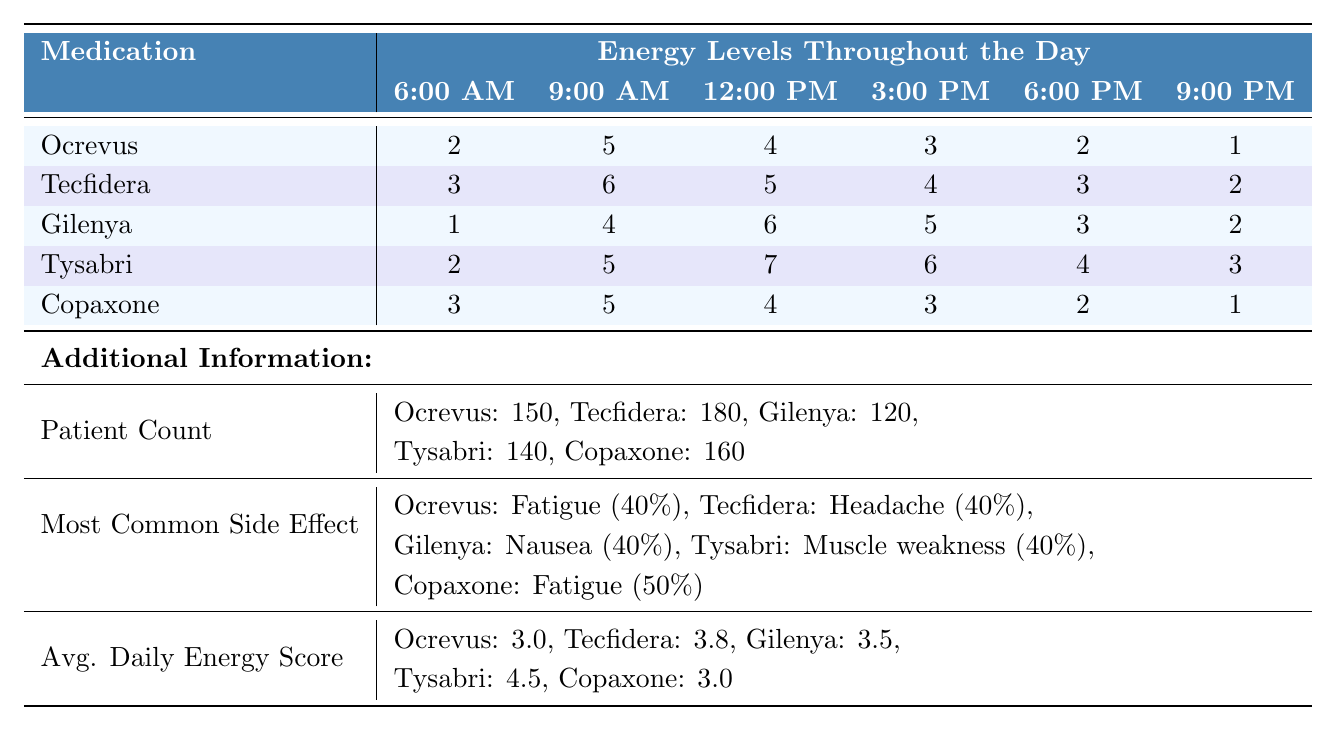What is the energy level for patients taking Tysabri at 12:00 PM? Referring to the table, the energy level for Tysabri at 12:00 PM is found in the corresponding cell, which shows the value of 7.
Answer: 7 What medication shows the highest average daily energy score? The average daily energy scores for each medication are listed. Comparing these values, Tysabri has the highest score at 4.5.
Answer: Tysabri How many patients are on Tecfidera? The table provides the patient count for Tecfidera, which is explicitly mentioned as 180.
Answer: 180 Which medication has the most common side effect of fatigue? By checking the side effects for each medication, we note that Ocrevus and Copaxone both list fatigue as a side effect, but Ocrevus has a frequency of 40%.
Answer: Ocrevus What is the difference in energy level at 9:00 AM between Gilenya and Copaxone? The energy level for Gilenya at 9:00 AM is 4, while Copaxone's is 5. The difference is calculated as 5 - 4 = 1.
Answer: 1 Which time of day has the highest average energy level across all medications? Calculating the average energy level for each time of day involves summing the values for each medication at that time. For example, for 6:00 AM: (2 + 3 + 1 + 2 + 3) = 11, divided by 5 gives an average of 2.2. After calculating, it is found that 12:00 PM has the highest average of 5.
Answer: 12:00 PM Is the side effect of nausea more common for Gilenya or Tecfidera? Looking at the side effect frequencies, nausea occurs at a frequency of 40% for Gilenya and 20% for Tecfidera, confirming that nausea is more common for Gilenya.
Answer: Yes What is the average energy level for patients taking Ocrevus throughout the day? The energy levels for Ocrevus are 2, 5, 4, 3, 2, and 1. The average is calculated as (2 + 5 + 4 + 3 + 2 + 1) / 6 = 2.83.
Answer: 2.83 If a patient experienced muscle weakness, which medication are they most likely taking? The table shows that muscle weakness is the most common side effect for Tysabri, indicating that a patient experiencing this side effect is most likely taking Tysabri.
Answer: Tysabri What medication has the lowest energy level at 9:00 AM? By examining the table, we find that the energy level at 9:00 AM for Gilenya is the lowest at 4 compared to other medications.
Answer: Gilenya 